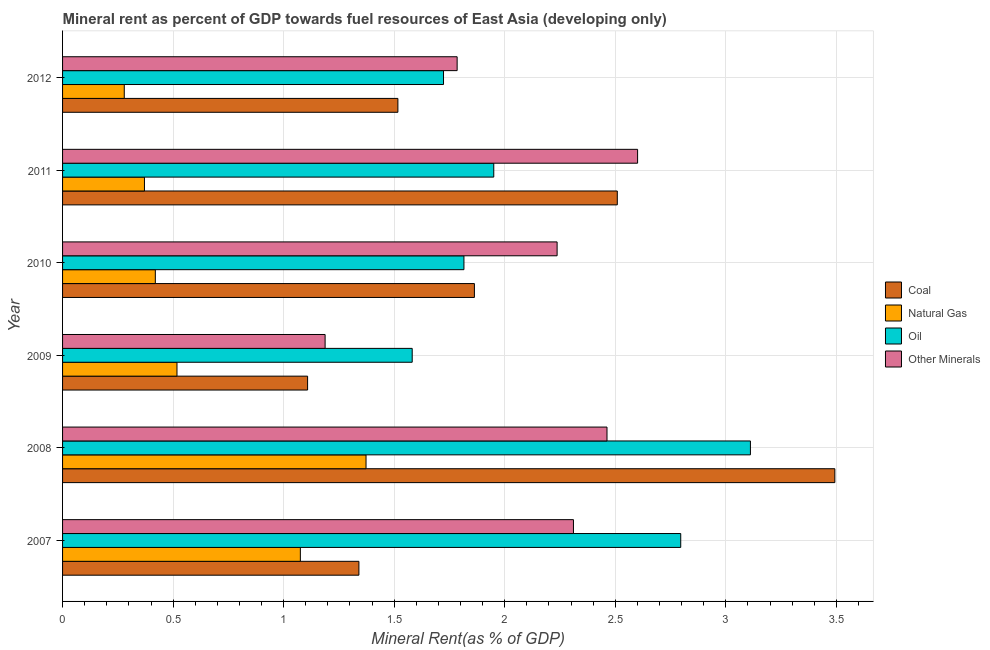How many different coloured bars are there?
Make the answer very short. 4. Are the number of bars on each tick of the Y-axis equal?
Offer a very short reply. Yes. How many bars are there on the 6th tick from the top?
Make the answer very short. 4. How many bars are there on the 4th tick from the bottom?
Ensure brevity in your answer.  4. What is the label of the 1st group of bars from the top?
Provide a succinct answer. 2012. In how many cases, is the number of bars for a given year not equal to the number of legend labels?
Provide a short and direct response. 0. What is the oil rent in 2009?
Your answer should be very brief. 1.58. Across all years, what is the maximum coal rent?
Keep it short and to the point. 3.49. Across all years, what is the minimum coal rent?
Your answer should be compact. 1.11. In which year was the natural gas rent minimum?
Offer a very short reply. 2012. What is the total coal rent in the graph?
Your answer should be very brief. 11.83. What is the difference between the coal rent in 2008 and that in 2012?
Your answer should be very brief. 1.98. What is the difference between the  rent of other minerals in 2010 and the oil rent in 2011?
Your answer should be compact. 0.29. What is the average oil rent per year?
Keep it short and to the point. 2.16. In the year 2012, what is the difference between the natural gas rent and  rent of other minerals?
Keep it short and to the point. -1.51. What is the ratio of the oil rent in 2007 to that in 2010?
Keep it short and to the point. 1.54. Is the coal rent in 2007 less than that in 2009?
Your answer should be very brief. No. Is the difference between the oil rent in 2007 and 2008 greater than the difference between the natural gas rent in 2007 and 2008?
Make the answer very short. No. What is the difference between the highest and the second highest natural gas rent?
Ensure brevity in your answer.  0.3. What is the difference between the highest and the lowest oil rent?
Ensure brevity in your answer.  1.53. In how many years, is the coal rent greater than the average coal rent taken over all years?
Your answer should be very brief. 2. Is the sum of the natural gas rent in 2007 and 2012 greater than the maximum  rent of other minerals across all years?
Keep it short and to the point. No. Is it the case that in every year, the sum of the natural gas rent and  rent of other minerals is greater than the sum of oil rent and coal rent?
Your response must be concise. No. What does the 1st bar from the top in 2008 represents?
Keep it short and to the point. Other Minerals. What does the 4th bar from the bottom in 2012 represents?
Provide a succinct answer. Other Minerals. What is the difference between two consecutive major ticks on the X-axis?
Provide a short and direct response. 0.5. Does the graph contain grids?
Keep it short and to the point. Yes. What is the title of the graph?
Your answer should be compact. Mineral rent as percent of GDP towards fuel resources of East Asia (developing only). What is the label or title of the X-axis?
Ensure brevity in your answer.  Mineral Rent(as % of GDP). What is the label or title of the Y-axis?
Your answer should be very brief. Year. What is the Mineral Rent(as % of GDP) in Coal in 2007?
Provide a short and direct response. 1.34. What is the Mineral Rent(as % of GDP) of Natural Gas in 2007?
Ensure brevity in your answer.  1.08. What is the Mineral Rent(as % of GDP) in Oil in 2007?
Your response must be concise. 2.8. What is the Mineral Rent(as % of GDP) of Other Minerals in 2007?
Your answer should be very brief. 2.31. What is the Mineral Rent(as % of GDP) in Coal in 2008?
Your answer should be compact. 3.49. What is the Mineral Rent(as % of GDP) in Natural Gas in 2008?
Keep it short and to the point. 1.37. What is the Mineral Rent(as % of GDP) of Oil in 2008?
Your answer should be very brief. 3.11. What is the Mineral Rent(as % of GDP) of Other Minerals in 2008?
Provide a short and direct response. 2.46. What is the Mineral Rent(as % of GDP) of Coal in 2009?
Offer a terse response. 1.11. What is the Mineral Rent(as % of GDP) of Natural Gas in 2009?
Keep it short and to the point. 0.52. What is the Mineral Rent(as % of GDP) in Oil in 2009?
Give a very brief answer. 1.58. What is the Mineral Rent(as % of GDP) of Other Minerals in 2009?
Offer a terse response. 1.19. What is the Mineral Rent(as % of GDP) of Coal in 2010?
Provide a short and direct response. 1.86. What is the Mineral Rent(as % of GDP) of Natural Gas in 2010?
Offer a terse response. 0.42. What is the Mineral Rent(as % of GDP) of Oil in 2010?
Your response must be concise. 1.82. What is the Mineral Rent(as % of GDP) in Other Minerals in 2010?
Offer a terse response. 2.24. What is the Mineral Rent(as % of GDP) in Coal in 2011?
Your response must be concise. 2.51. What is the Mineral Rent(as % of GDP) in Natural Gas in 2011?
Your response must be concise. 0.37. What is the Mineral Rent(as % of GDP) of Oil in 2011?
Provide a short and direct response. 1.95. What is the Mineral Rent(as % of GDP) of Other Minerals in 2011?
Provide a succinct answer. 2.6. What is the Mineral Rent(as % of GDP) in Coal in 2012?
Ensure brevity in your answer.  1.52. What is the Mineral Rent(as % of GDP) of Natural Gas in 2012?
Your response must be concise. 0.28. What is the Mineral Rent(as % of GDP) of Oil in 2012?
Keep it short and to the point. 1.72. What is the Mineral Rent(as % of GDP) in Other Minerals in 2012?
Provide a short and direct response. 1.78. Across all years, what is the maximum Mineral Rent(as % of GDP) in Coal?
Offer a very short reply. 3.49. Across all years, what is the maximum Mineral Rent(as % of GDP) in Natural Gas?
Your answer should be very brief. 1.37. Across all years, what is the maximum Mineral Rent(as % of GDP) in Oil?
Your answer should be compact. 3.11. Across all years, what is the maximum Mineral Rent(as % of GDP) of Other Minerals?
Your answer should be compact. 2.6. Across all years, what is the minimum Mineral Rent(as % of GDP) of Coal?
Your answer should be very brief. 1.11. Across all years, what is the minimum Mineral Rent(as % of GDP) in Natural Gas?
Give a very brief answer. 0.28. Across all years, what is the minimum Mineral Rent(as % of GDP) of Oil?
Offer a terse response. 1.58. Across all years, what is the minimum Mineral Rent(as % of GDP) in Other Minerals?
Give a very brief answer. 1.19. What is the total Mineral Rent(as % of GDP) of Coal in the graph?
Your response must be concise. 11.83. What is the total Mineral Rent(as % of GDP) of Natural Gas in the graph?
Your answer should be very brief. 4.03. What is the total Mineral Rent(as % of GDP) of Oil in the graph?
Your answer should be very brief. 12.98. What is the total Mineral Rent(as % of GDP) of Other Minerals in the graph?
Provide a short and direct response. 12.58. What is the difference between the Mineral Rent(as % of GDP) in Coal in 2007 and that in 2008?
Give a very brief answer. -2.15. What is the difference between the Mineral Rent(as % of GDP) of Natural Gas in 2007 and that in 2008?
Offer a very short reply. -0.3. What is the difference between the Mineral Rent(as % of GDP) of Oil in 2007 and that in 2008?
Your answer should be very brief. -0.32. What is the difference between the Mineral Rent(as % of GDP) in Other Minerals in 2007 and that in 2008?
Provide a short and direct response. -0.15. What is the difference between the Mineral Rent(as % of GDP) of Coal in 2007 and that in 2009?
Provide a succinct answer. 0.23. What is the difference between the Mineral Rent(as % of GDP) of Natural Gas in 2007 and that in 2009?
Your answer should be very brief. 0.56. What is the difference between the Mineral Rent(as % of GDP) of Oil in 2007 and that in 2009?
Keep it short and to the point. 1.21. What is the difference between the Mineral Rent(as % of GDP) of Other Minerals in 2007 and that in 2009?
Keep it short and to the point. 1.12. What is the difference between the Mineral Rent(as % of GDP) of Coal in 2007 and that in 2010?
Keep it short and to the point. -0.52. What is the difference between the Mineral Rent(as % of GDP) of Natural Gas in 2007 and that in 2010?
Ensure brevity in your answer.  0.66. What is the difference between the Mineral Rent(as % of GDP) in Oil in 2007 and that in 2010?
Ensure brevity in your answer.  0.98. What is the difference between the Mineral Rent(as % of GDP) of Other Minerals in 2007 and that in 2010?
Provide a succinct answer. 0.07. What is the difference between the Mineral Rent(as % of GDP) in Coal in 2007 and that in 2011?
Offer a terse response. -1.17. What is the difference between the Mineral Rent(as % of GDP) in Natural Gas in 2007 and that in 2011?
Offer a very short reply. 0.71. What is the difference between the Mineral Rent(as % of GDP) in Oil in 2007 and that in 2011?
Your response must be concise. 0.85. What is the difference between the Mineral Rent(as % of GDP) of Other Minerals in 2007 and that in 2011?
Ensure brevity in your answer.  -0.29. What is the difference between the Mineral Rent(as % of GDP) of Coal in 2007 and that in 2012?
Keep it short and to the point. -0.18. What is the difference between the Mineral Rent(as % of GDP) in Natural Gas in 2007 and that in 2012?
Your answer should be compact. 0.8. What is the difference between the Mineral Rent(as % of GDP) in Oil in 2007 and that in 2012?
Provide a succinct answer. 1.07. What is the difference between the Mineral Rent(as % of GDP) of Other Minerals in 2007 and that in 2012?
Offer a very short reply. 0.53. What is the difference between the Mineral Rent(as % of GDP) of Coal in 2008 and that in 2009?
Your answer should be compact. 2.38. What is the difference between the Mineral Rent(as % of GDP) of Natural Gas in 2008 and that in 2009?
Your answer should be compact. 0.86. What is the difference between the Mineral Rent(as % of GDP) in Oil in 2008 and that in 2009?
Your answer should be compact. 1.53. What is the difference between the Mineral Rent(as % of GDP) of Other Minerals in 2008 and that in 2009?
Offer a very short reply. 1.28. What is the difference between the Mineral Rent(as % of GDP) of Coal in 2008 and that in 2010?
Make the answer very short. 1.63. What is the difference between the Mineral Rent(as % of GDP) in Natural Gas in 2008 and that in 2010?
Provide a short and direct response. 0.95. What is the difference between the Mineral Rent(as % of GDP) of Oil in 2008 and that in 2010?
Offer a terse response. 1.3. What is the difference between the Mineral Rent(as % of GDP) in Other Minerals in 2008 and that in 2010?
Give a very brief answer. 0.23. What is the difference between the Mineral Rent(as % of GDP) in Natural Gas in 2008 and that in 2011?
Keep it short and to the point. 1. What is the difference between the Mineral Rent(as % of GDP) in Oil in 2008 and that in 2011?
Your answer should be very brief. 1.16. What is the difference between the Mineral Rent(as % of GDP) of Other Minerals in 2008 and that in 2011?
Provide a succinct answer. -0.14. What is the difference between the Mineral Rent(as % of GDP) in Coal in 2008 and that in 2012?
Your answer should be compact. 1.98. What is the difference between the Mineral Rent(as % of GDP) in Natural Gas in 2008 and that in 2012?
Provide a short and direct response. 1.09. What is the difference between the Mineral Rent(as % of GDP) in Oil in 2008 and that in 2012?
Provide a short and direct response. 1.39. What is the difference between the Mineral Rent(as % of GDP) in Other Minerals in 2008 and that in 2012?
Your response must be concise. 0.68. What is the difference between the Mineral Rent(as % of GDP) in Coal in 2009 and that in 2010?
Your response must be concise. -0.75. What is the difference between the Mineral Rent(as % of GDP) of Natural Gas in 2009 and that in 2010?
Offer a very short reply. 0.1. What is the difference between the Mineral Rent(as % of GDP) of Oil in 2009 and that in 2010?
Your answer should be compact. -0.23. What is the difference between the Mineral Rent(as % of GDP) of Other Minerals in 2009 and that in 2010?
Keep it short and to the point. -1.05. What is the difference between the Mineral Rent(as % of GDP) of Coal in 2009 and that in 2011?
Provide a short and direct response. -1.4. What is the difference between the Mineral Rent(as % of GDP) of Natural Gas in 2009 and that in 2011?
Provide a short and direct response. 0.15. What is the difference between the Mineral Rent(as % of GDP) in Oil in 2009 and that in 2011?
Provide a short and direct response. -0.37. What is the difference between the Mineral Rent(as % of GDP) in Other Minerals in 2009 and that in 2011?
Ensure brevity in your answer.  -1.41. What is the difference between the Mineral Rent(as % of GDP) of Coal in 2009 and that in 2012?
Make the answer very short. -0.41. What is the difference between the Mineral Rent(as % of GDP) of Natural Gas in 2009 and that in 2012?
Your response must be concise. 0.24. What is the difference between the Mineral Rent(as % of GDP) of Oil in 2009 and that in 2012?
Keep it short and to the point. -0.14. What is the difference between the Mineral Rent(as % of GDP) of Other Minerals in 2009 and that in 2012?
Offer a terse response. -0.6. What is the difference between the Mineral Rent(as % of GDP) of Coal in 2010 and that in 2011?
Offer a very short reply. -0.65. What is the difference between the Mineral Rent(as % of GDP) in Natural Gas in 2010 and that in 2011?
Make the answer very short. 0.05. What is the difference between the Mineral Rent(as % of GDP) in Oil in 2010 and that in 2011?
Offer a very short reply. -0.13. What is the difference between the Mineral Rent(as % of GDP) of Other Minerals in 2010 and that in 2011?
Give a very brief answer. -0.36. What is the difference between the Mineral Rent(as % of GDP) of Coal in 2010 and that in 2012?
Provide a short and direct response. 0.35. What is the difference between the Mineral Rent(as % of GDP) in Natural Gas in 2010 and that in 2012?
Provide a short and direct response. 0.14. What is the difference between the Mineral Rent(as % of GDP) of Oil in 2010 and that in 2012?
Your answer should be compact. 0.09. What is the difference between the Mineral Rent(as % of GDP) in Other Minerals in 2010 and that in 2012?
Offer a very short reply. 0.45. What is the difference between the Mineral Rent(as % of GDP) of Natural Gas in 2011 and that in 2012?
Your answer should be very brief. 0.09. What is the difference between the Mineral Rent(as % of GDP) in Oil in 2011 and that in 2012?
Your answer should be very brief. 0.23. What is the difference between the Mineral Rent(as % of GDP) in Other Minerals in 2011 and that in 2012?
Offer a very short reply. 0.82. What is the difference between the Mineral Rent(as % of GDP) in Coal in 2007 and the Mineral Rent(as % of GDP) in Natural Gas in 2008?
Offer a very short reply. -0.03. What is the difference between the Mineral Rent(as % of GDP) of Coal in 2007 and the Mineral Rent(as % of GDP) of Oil in 2008?
Your response must be concise. -1.77. What is the difference between the Mineral Rent(as % of GDP) in Coal in 2007 and the Mineral Rent(as % of GDP) in Other Minerals in 2008?
Give a very brief answer. -1.12. What is the difference between the Mineral Rent(as % of GDP) of Natural Gas in 2007 and the Mineral Rent(as % of GDP) of Oil in 2008?
Offer a very short reply. -2.04. What is the difference between the Mineral Rent(as % of GDP) of Natural Gas in 2007 and the Mineral Rent(as % of GDP) of Other Minerals in 2008?
Offer a very short reply. -1.39. What is the difference between the Mineral Rent(as % of GDP) of Oil in 2007 and the Mineral Rent(as % of GDP) of Other Minerals in 2008?
Keep it short and to the point. 0.33. What is the difference between the Mineral Rent(as % of GDP) of Coal in 2007 and the Mineral Rent(as % of GDP) of Natural Gas in 2009?
Provide a short and direct response. 0.82. What is the difference between the Mineral Rent(as % of GDP) of Coal in 2007 and the Mineral Rent(as % of GDP) of Oil in 2009?
Give a very brief answer. -0.24. What is the difference between the Mineral Rent(as % of GDP) in Coal in 2007 and the Mineral Rent(as % of GDP) in Other Minerals in 2009?
Your answer should be compact. 0.15. What is the difference between the Mineral Rent(as % of GDP) in Natural Gas in 2007 and the Mineral Rent(as % of GDP) in Oil in 2009?
Your response must be concise. -0.51. What is the difference between the Mineral Rent(as % of GDP) in Natural Gas in 2007 and the Mineral Rent(as % of GDP) in Other Minerals in 2009?
Ensure brevity in your answer.  -0.11. What is the difference between the Mineral Rent(as % of GDP) in Oil in 2007 and the Mineral Rent(as % of GDP) in Other Minerals in 2009?
Your answer should be very brief. 1.61. What is the difference between the Mineral Rent(as % of GDP) of Coal in 2007 and the Mineral Rent(as % of GDP) of Natural Gas in 2010?
Your answer should be compact. 0.92. What is the difference between the Mineral Rent(as % of GDP) of Coal in 2007 and the Mineral Rent(as % of GDP) of Oil in 2010?
Your answer should be compact. -0.47. What is the difference between the Mineral Rent(as % of GDP) of Coal in 2007 and the Mineral Rent(as % of GDP) of Other Minerals in 2010?
Provide a succinct answer. -0.9. What is the difference between the Mineral Rent(as % of GDP) of Natural Gas in 2007 and the Mineral Rent(as % of GDP) of Oil in 2010?
Offer a very short reply. -0.74. What is the difference between the Mineral Rent(as % of GDP) in Natural Gas in 2007 and the Mineral Rent(as % of GDP) in Other Minerals in 2010?
Make the answer very short. -1.16. What is the difference between the Mineral Rent(as % of GDP) in Oil in 2007 and the Mineral Rent(as % of GDP) in Other Minerals in 2010?
Your answer should be very brief. 0.56. What is the difference between the Mineral Rent(as % of GDP) in Coal in 2007 and the Mineral Rent(as % of GDP) in Natural Gas in 2011?
Offer a terse response. 0.97. What is the difference between the Mineral Rent(as % of GDP) of Coal in 2007 and the Mineral Rent(as % of GDP) of Oil in 2011?
Provide a succinct answer. -0.61. What is the difference between the Mineral Rent(as % of GDP) of Coal in 2007 and the Mineral Rent(as % of GDP) of Other Minerals in 2011?
Your answer should be very brief. -1.26. What is the difference between the Mineral Rent(as % of GDP) of Natural Gas in 2007 and the Mineral Rent(as % of GDP) of Oil in 2011?
Give a very brief answer. -0.87. What is the difference between the Mineral Rent(as % of GDP) of Natural Gas in 2007 and the Mineral Rent(as % of GDP) of Other Minerals in 2011?
Your answer should be very brief. -1.53. What is the difference between the Mineral Rent(as % of GDP) in Oil in 2007 and the Mineral Rent(as % of GDP) in Other Minerals in 2011?
Your answer should be very brief. 0.2. What is the difference between the Mineral Rent(as % of GDP) of Coal in 2007 and the Mineral Rent(as % of GDP) of Natural Gas in 2012?
Make the answer very short. 1.06. What is the difference between the Mineral Rent(as % of GDP) of Coal in 2007 and the Mineral Rent(as % of GDP) of Oil in 2012?
Your response must be concise. -0.38. What is the difference between the Mineral Rent(as % of GDP) of Coal in 2007 and the Mineral Rent(as % of GDP) of Other Minerals in 2012?
Your answer should be very brief. -0.44. What is the difference between the Mineral Rent(as % of GDP) of Natural Gas in 2007 and the Mineral Rent(as % of GDP) of Oil in 2012?
Your response must be concise. -0.65. What is the difference between the Mineral Rent(as % of GDP) of Natural Gas in 2007 and the Mineral Rent(as % of GDP) of Other Minerals in 2012?
Keep it short and to the point. -0.71. What is the difference between the Mineral Rent(as % of GDP) of Oil in 2007 and the Mineral Rent(as % of GDP) of Other Minerals in 2012?
Give a very brief answer. 1.01. What is the difference between the Mineral Rent(as % of GDP) of Coal in 2008 and the Mineral Rent(as % of GDP) of Natural Gas in 2009?
Provide a succinct answer. 2.98. What is the difference between the Mineral Rent(as % of GDP) in Coal in 2008 and the Mineral Rent(as % of GDP) in Oil in 2009?
Provide a short and direct response. 1.91. What is the difference between the Mineral Rent(as % of GDP) of Coal in 2008 and the Mineral Rent(as % of GDP) of Other Minerals in 2009?
Ensure brevity in your answer.  2.31. What is the difference between the Mineral Rent(as % of GDP) of Natural Gas in 2008 and the Mineral Rent(as % of GDP) of Oil in 2009?
Your answer should be very brief. -0.21. What is the difference between the Mineral Rent(as % of GDP) in Natural Gas in 2008 and the Mineral Rent(as % of GDP) in Other Minerals in 2009?
Ensure brevity in your answer.  0.19. What is the difference between the Mineral Rent(as % of GDP) in Oil in 2008 and the Mineral Rent(as % of GDP) in Other Minerals in 2009?
Offer a terse response. 1.92. What is the difference between the Mineral Rent(as % of GDP) in Coal in 2008 and the Mineral Rent(as % of GDP) in Natural Gas in 2010?
Provide a succinct answer. 3.07. What is the difference between the Mineral Rent(as % of GDP) in Coal in 2008 and the Mineral Rent(as % of GDP) in Oil in 2010?
Offer a terse response. 1.68. What is the difference between the Mineral Rent(as % of GDP) of Coal in 2008 and the Mineral Rent(as % of GDP) of Other Minerals in 2010?
Offer a terse response. 1.26. What is the difference between the Mineral Rent(as % of GDP) in Natural Gas in 2008 and the Mineral Rent(as % of GDP) in Oil in 2010?
Your response must be concise. -0.44. What is the difference between the Mineral Rent(as % of GDP) of Natural Gas in 2008 and the Mineral Rent(as % of GDP) of Other Minerals in 2010?
Ensure brevity in your answer.  -0.86. What is the difference between the Mineral Rent(as % of GDP) in Oil in 2008 and the Mineral Rent(as % of GDP) in Other Minerals in 2010?
Give a very brief answer. 0.87. What is the difference between the Mineral Rent(as % of GDP) in Coal in 2008 and the Mineral Rent(as % of GDP) in Natural Gas in 2011?
Provide a short and direct response. 3.12. What is the difference between the Mineral Rent(as % of GDP) in Coal in 2008 and the Mineral Rent(as % of GDP) in Oil in 2011?
Offer a very short reply. 1.54. What is the difference between the Mineral Rent(as % of GDP) of Coal in 2008 and the Mineral Rent(as % of GDP) of Other Minerals in 2011?
Give a very brief answer. 0.89. What is the difference between the Mineral Rent(as % of GDP) in Natural Gas in 2008 and the Mineral Rent(as % of GDP) in Oil in 2011?
Offer a terse response. -0.58. What is the difference between the Mineral Rent(as % of GDP) of Natural Gas in 2008 and the Mineral Rent(as % of GDP) of Other Minerals in 2011?
Give a very brief answer. -1.23. What is the difference between the Mineral Rent(as % of GDP) in Oil in 2008 and the Mineral Rent(as % of GDP) in Other Minerals in 2011?
Provide a short and direct response. 0.51. What is the difference between the Mineral Rent(as % of GDP) of Coal in 2008 and the Mineral Rent(as % of GDP) of Natural Gas in 2012?
Your response must be concise. 3.21. What is the difference between the Mineral Rent(as % of GDP) in Coal in 2008 and the Mineral Rent(as % of GDP) in Oil in 2012?
Keep it short and to the point. 1.77. What is the difference between the Mineral Rent(as % of GDP) of Coal in 2008 and the Mineral Rent(as % of GDP) of Other Minerals in 2012?
Provide a succinct answer. 1.71. What is the difference between the Mineral Rent(as % of GDP) in Natural Gas in 2008 and the Mineral Rent(as % of GDP) in Oil in 2012?
Your response must be concise. -0.35. What is the difference between the Mineral Rent(as % of GDP) of Natural Gas in 2008 and the Mineral Rent(as % of GDP) of Other Minerals in 2012?
Ensure brevity in your answer.  -0.41. What is the difference between the Mineral Rent(as % of GDP) of Oil in 2008 and the Mineral Rent(as % of GDP) of Other Minerals in 2012?
Your answer should be very brief. 1.33. What is the difference between the Mineral Rent(as % of GDP) in Coal in 2009 and the Mineral Rent(as % of GDP) in Natural Gas in 2010?
Make the answer very short. 0.69. What is the difference between the Mineral Rent(as % of GDP) in Coal in 2009 and the Mineral Rent(as % of GDP) in Oil in 2010?
Provide a succinct answer. -0.71. What is the difference between the Mineral Rent(as % of GDP) in Coal in 2009 and the Mineral Rent(as % of GDP) in Other Minerals in 2010?
Ensure brevity in your answer.  -1.13. What is the difference between the Mineral Rent(as % of GDP) of Natural Gas in 2009 and the Mineral Rent(as % of GDP) of Oil in 2010?
Offer a very short reply. -1.3. What is the difference between the Mineral Rent(as % of GDP) of Natural Gas in 2009 and the Mineral Rent(as % of GDP) of Other Minerals in 2010?
Give a very brief answer. -1.72. What is the difference between the Mineral Rent(as % of GDP) of Oil in 2009 and the Mineral Rent(as % of GDP) of Other Minerals in 2010?
Your answer should be compact. -0.66. What is the difference between the Mineral Rent(as % of GDP) of Coal in 2009 and the Mineral Rent(as % of GDP) of Natural Gas in 2011?
Provide a short and direct response. 0.74. What is the difference between the Mineral Rent(as % of GDP) of Coal in 2009 and the Mineral Rent(as % of GDP) of Oil in 2011?
Ensure brevity in your answer.  -0.84. What is the difference between the Mineral Rent(as % of GDP) in Coal in 2009 and the Mineral Rent(as % of GDP) in Other Minerals in 2011?
Make the answer very short. -1.49. What is the difference between the Mineral Rent(as % of GDP) in Natural Gas in 2009 and the Mineral Rent(as % of GDP) in Oil in 2011?
Give a very brief answer. -1.43. What is the difference between the Mineral Rent(as % of GDP) of Natural Gas in 2009 and the Mineral Rent(as % of GDP) of Other Minerals in 2011?
Your response must be concise. -2.08. What is the difference between the Mineral Rent(as % of GDP) in Oil in 2009 and the Mineral Rent(as % of GDP) in Other Minerals in 2011?
Provide a succinct answer. -1.02. What is the difference between the Mineral Rent(as % of GDP) of Coal in 2009 and the Mineral Rent(as % of GDP) of Natural Gas in 2012?
Ensure brevity in your answer.  0.83. What is the difference between the Mineral Rent(as % of GDP) of Coal in 2009 and the Mineral Rent(as % of GDP) of Oil in 2012?
Give a very brief answer. -0.61. What is the difference between the Mineral Rent(as % of GDP) of Coal in 2009 and the Mineral Rent(as % of GDP) of Other Minerals in 2012?
Provide a succinct answer. -0.68. What is the difference between the Mineral Rent(as % of GDP) in Natural Gas in 2009 and the Mineral Rent(as % of GDP) in Oil in 2012?
Provide a short and direct response. -1.21. What is the difference between the Mineral Rent(as % of GDP) in Natural Gas in 2009 and the Mineral Rent(as % of GDP) in Other Minerals in 2012?
Provide a short and direct response. -1.27. What is the difference between the Mineral Rent(as % of GDP) in Oil in 2009 and the Mineral Rent(as % of GDP) in Other Minerals in 2012?
Keep it short and to the point. -0.2. What is the difference between the Mineral Rent(as % of GDP) of Coal in 2010 and the Mineral Rent(as % of GDP) of Natural Gas in 2011?
Provide a succinct answer. 1.49. What is the difference between the Mineral Rent(as % of GDP) of Coal in 2010 and the Mineral Rent(as % of GDP) of Oil in 2011?
Offer a terse response. -0.09. What is the difference between the Mineral Rent(as % of GDP) of Coal in 2010 and the Mineral Rent(as % of GDP) of Other Minerals in 2011?
Provide a succinct answer. -0.74. What is the difference between the Mineral Rent(as % of GDP) of Natural Gas in 2010 and the Mineral Rent(as % of GDP) of Oil in 2011?
Provide a succinct answer. -1.53. What is the difference between the Mineral Rent(as % of GDP) of Natural Gas in 2010 and the Mineral Rent(as % of GDP) of Other Minerals in 2011?
Your response must be concise. -2.18. What is the difference between the Mineral Rent(as % of GDP) in Oil in 2010 and the Mineral Rent(as % of GDP) in Other Minerals in 2011?
Offer a very short reply. -0.79. What is the difference between the Mineral Rent(as % of GDP) in Coal in 2010 and the Mineral Rent(as % of GDP) in Natural Gas in 2012?
Ensure brevity in your answer.  1.58. What is the difference between the Mineral Rent(as % of GDP) of Coal in 2010 and the Mineral Rent(as % of GDP) of Oil in 2012?
Keep it short and to the point. 0.14. What is the difference between the Mineral Rent(as % of GDP) of Coal in 2010 and the Mineral Rent(as % of GDP) of Other Minerals in 2012?
Provide a short and direct response. 0.08. What is the difference between the Mineral Rent(as % of GDP) in Natural Gas in 2010 and the Mineral Rent(as % of GDP) in Oil in 2012?
Give a very brief answer. -1.3. What is the difference between the Mineral Rent(as % of GDP) of Natural Gas in 2010 and the Mineral Rent(as % of GDP) of Other Minerals in 2012?
Your answer should be compact. -1.37. What is the difference between the Mineral Rent(as % of GDP) in Oil in 2010 and the Mineral Rent(as % of GDP) in Other Minerals in 2012?
Ensure brevity in your answer.  0.03. What is the difference between the Mineral Rent(as % of GDP) in Coal in 2011 and the Mineral Rent(as % of GDP) in Natural Gas in 2012?
Give a very brief answer. 2.23. What is the difference between the Mineral Rent(as % of GDP) in Coal in 2011 and the Mineral Rent(as % of GDP) in Oil in 2012?
Offer a very short reply. 0.79. What is the difference between the Mineral Rent(as % of GDP) in Coal in 2011 and the Mineral Rent(as % of GDP) in Other Minerals in 2012?
Provide a succinct answer. 0.72. What is the difference between the Mineral Rent(as % of GDP) in Natural Gas in 2011 and the Mineral Rent(as % of GDP) in Oil in 2012?
Your answer should be compact. -1.35. What is the difference between the Mineral Rent(as % of GDP) in Natural Gas in 2011 and the Mineral Rent(as % of GDP) in Other Minerals in 2012?
Your answer should be very brief. -1.41. What is the difference between the Mineral Rent(as % of GDP) of Oil in 2011 and the Mineral Rent(as % of GDP) of Other Minerals in 2012?
Make the answer very short. 0.17. What is the average Mineral Rent(as % of GDP) of Coal per year?
Provide a succinct answer. 1.97. What is the average Mineral Rent(as % of GDP) in Natural Gas per year?
Offer a terse response. 0.67. What is the average Mineral Rent(as % of GDP) in Oil per year?
Provide a short and direct response. 2.16. What is the average Mineral Rent(as % of GDP) of Other Minerals per year?
Give a very brief answer. 2.1. In the year 2007, what is the difference between the Mineral Rent(as % of GDP) in Coal and Mineral Rent(as % of GDP) in Natural Gas?
Make the answer very short. 0.26. In the year 2007, what is the difference between the Mineral Rent(as % of GDP) in Coal and Mineral Rent(as % of GDP) in Oil?
Ensure brevity in your answer.  -1.46. In the year 2007, what is the difference between the Mineral Rent(as % of GDP) of Coal and Mineral Rent(as % of GDP) of Other Minerals?
Keep it short and to the point. -0.97. In the year 2007, what is the difference between the Mineral Rent(as % of GDP) of Natural Gas and Mineral Rent(as % of GDP) of Oil?
Your answer should be very brief. -1.72. In the year 2007, what is the difference between the Mineral Rent(as % of GDP) of Natural Gas and Mineral Rent(as % of GDP) of Other Minerals?
Ensure brevity in your answer.  -1.24. In the year 2007, what is the difference between the Mineral Rent(as % of GDP) in Oil and Mineral Rent(as % of GDP) in Other Minerals?
Offer a terse response. 0.49. In the year 2008, what is the difference between the Mineral Rent(as % of GDP) of Coal and Mineral Rent(as % of GDP) of Natural Gas?
Your answer should be compact. 2.12. In the year 2008, what is the difference between the Mineral Rent(as % of GDP) of Coal and Mineral Rent(as % of GDP) of Oil?
Provide a succinct answer. 0.38. In the year 2008, what is the difference between the Mineral Rent(as % of GDP) of Coal and Mineral Rent(as % of GDP) of Other Minerals?
Make the answer very short. 1.03. In the year 2008, what is the difference between the Mineral Rent(as % of GDP) in Natural Gas and Mineral Rent(as % of GDP) in Oil?
Your answer should be compact. -1.74. In the year 2008, what is the difference between the Mineral Rent(as % of GDP) of Natural Gas and Mineral Rent(as % of GDP) of Other Minerals?
Offer a very short reply. -1.09. In the year 2008, what is the difference between the Mineral Rent(as % of GDP) in Oil and Mineral Rent(as % of GDP) in Other Minerals?
Ensure brevity in your answer.  0.65. In the year 2009, what is the difference between the Mineral Rent(as % of GDP) of Coal and Mineral Rent(as % of GDP) of Natural Gas?
Offer a very short reply. 0.59. In the year 2009, what is the difference between the Mineral Rent(as % of GDP) in Coal and Mineral Rent(as % of GDP) in Oil?
Your answer should be very brief. -0.47. In the year 2009, what is the difference between the Mineral Rent(as % of GDP) in Coal and Mineral Rent(as % of GDP) in Other Minerals?
Your answer should be very brief. -0.08. In the year 2009, what is the difference between the Mineral Rent(as % of GDP) of Natural Gas and Mineral Rent(as % of GDP) of Oil?
Provide a succinct answer. -1.06. In the year 2009, what is the difference between the Mineral Rent(as % of GDP) in Natural Gas and Mineral Rent(as % of GDP) in Other Minerals?
Keep it short and to the point. -0.67. In the year 2009, what is the difference between the Mineral Rent(as % of GDP) in Oil and Mineral Rent(as % of GDP) in Other Minerals?
Offer a very short reply. 0.39. In the year 2010, what is the difference between the Mineral Rent(as % of GDP) in Coal and Mineral Rent(as % of GDP) in Natural Gas?
Offer a terse response. 1.44. In the year 2010, what is the difference between the Mineral Rent(as % of GDP) in Coal and Mineral Rent(as % of GDP) in Oil?
Keep it short and to the point. 0.05. In the year 2010, what is the difference between the Mineral Rent(as % of GDP) in Coal and Mineral Rent(as % of GDP) in Other Minerals?
Ensure brevity in your answer.  -0.37. In the year 2010, what is the difference between the Mineral Rent(as % of GDP) of Natural Gas and Mineral Rent(as % of GDP) of Oil?
Make the answer very short. -1.4. In the year 2010, what is the difference between the Mineral Rent(as % of GDP) of Natural Gas and Mineral Rent(as % of GDP) of Other Minerals?
Ensure brevity in your answer.  -1.82. In the year 2010, what is the difference between the Mineral Rent(as % of GDP) in Oil and Mineral Rent(as % of GDP) in Other Minerals?
Offer a very short reply. -0.42. In the year 2011, what is the difference between the Mineral Rent(as % of GDP) in Coal and Mineral Rent(as % of GDP) in Natural Gas?
Your answer should be very brief. 2.14. In the year 2011, what is the difference between the Mineral Rent(as % of GDP) of Coal and Mineral Rent(as % of GDP) of Oil?
Provide a succinct answer. 0.56. In the year 2011, what is the difference between the Mineral Rent(as % of GDP) of Coal and Mineral Rent(as % of GDP) of Other Minerals?
Your answer should be very brief. -0.09. In the year 2011, what is the difference between the Mineral Rent(as % of GDP) of Natural Gas and Mineral Rent(as % of GDP) of Oil?
Provide a short and direct response. -1.58. In the year 2011, what is the difference between the Mineral Rent(as % of GDP) in Natural Gas and Mineral Rent(as % of GDP) in Other Minerals?
Give a very brief answer. -2.23. In the year 2011, what is the difference between the Mineral Rent(as % of GDP) in Oil and Mineral Rent(as % of GDP) in Other Minerals?
Provide a short and direct response. -0.65. In the year 2012, what is the difference between the Mineral Rent(as % of GDP) of Coal and Mineral Rent(as % of GDP) of Natural Gas?
Provide a short and direct response. 1.24. In the year 2012, what is the difference between the Mineral Rent(as % of GDP) of Coal and Mineral Rent(as % of GDP) of Oil?
Make the answer very short. -0.21. In the year 2012, what is the difference between the Mineral Rent(as % of GDP) in Coal and Mineral Rent(as % of GDP) in Other Minerals?
Provide a short and direct response. -0.27. In the year 2012, what is the difference between the Mineral Rent(as % of GDP) in Natural Gas and Mineral Rent(as % of GDP) in Oil?
Make the answer very short. -1.44. In the year 2012, what is the difference between the Mineral Rent(as % of GDP) in Natural Gas and Mineral Rent(as % of GDP) in Other Minerals?
Your answer should be very brief. -1.51. In the year 2012, what is the difference between the Mineral Rent(as % of GDP) of Oil and Mineral Rent(as % of GDP) of Other Minerals?
Offer a terse response. -0.06. What is the ratio of the Mineral Rent(as % of GDP) of Coal in 2007 to that in 2008?
Offer a very short reply. 0.38. What is the ratio of the Mineral Rent(as % of GDP) in Natural Gas in 2007 to that in 2008?
Your answer should be very brief. 0.78. What is the ratio of the Mineral Rent(as % of GDP) of Oil in 2007 to that in 2008?
Your answer should be compact. 0.9. What is the ratio of the Mineral Rent(as % of GDP) of Other Minerals in 2007 to that in 2008?
Your answer should be very brief. 0.94. What is the ratio of the Mineral Rent(as % of GDP) in Coal in 2007 to that in 2009?
Offer a very short reply. 1.21. What is the ratio of the Mineral Rent(as % of GDP) in Natural Gas in 2007 to that in 2009?
Provide a short and direct response. 2.08. What is the ratio of the Mineral Rent(as % of GDP) of Oil in 2007 to that in 2009?
Make the answer very short. 1.77. What is the ratio of the Mineral Rent(as % of GDP) of Other Minerals in 2007 to that in 2009?
Your answer should be very brief. 1.95. What is the ratio of the Mineral Rent(as % of GDP) in Coal in 2007 to that in 2010?
Keep it short and to the point. 0.72. What is the ratio of the Mineral Rent(as % of GDP) of Natural Gas in 2007 to that in 2010?
Make the answer very short. 2.56. What is the ratio of the Mineral Rent(as % of GDP) of Oil in 2007 to that in 2010?
Your answer should be very brief. 1.54. What is the ratio of the Mineral Rent(as % of GDP) of Other Minerals in 2007 to that in 2010?
Ensure brevity in your answer.  1.03. What is the ratio of the Mineral Rent(as % of GDP) of Coal in 2007 to that in 2011?
Your answer should be very brief. 0.53. What is the ratio of the Mineral Rent(as % of GDP) of Natural Gas in 2007 to that in 2011?
Keep it short and to the point. 2.9. What is the ratio of the Mineral Rent(as % of GDP) in Oil in 2007 to that in 2011?
Your response must be concise. 1.43. What is the ratio of the Mineral Rent(as % of GDP) of Other Minerals in 2007 to that in 2011?
Your answer should be compact. 0.89. What is the ratio of the Mineral Rent(as % of GDP) of Coal in 2007 to that in 2012?
Your answer should be compact. 0.88. What is the ratio of the Mineral Rent(as % of GDP) in Natural Gas in 2007 to that in 2012?
Ensure brevity in your answer.  3.85. What is the ratio of the Mineral Rent(as % of GDP) of Oil in 2007 to that in 2012?
Offer a terse response. 1.62. What is the ratio of the Mineral Rent(as % of GDP) of Other Minerals in 2007 to that in 2012?
Offer a very short reply. 1.29. What is the ratio of the Mineral Rent(as % of GDP) in Coal in 2008 to that in 2009?
Ensure brevity in your answer.  3.15. What is the ratio of the Mineral Rent(as % of GDP) in Natural Gas in 2008 to that in 2009?
Your answer should be compact. 2.65. What is the ratio of the Mineral Rent(as % of GDP) of Oil in 2008 to that in 2009?
Your answer should be very brief. 1.97. What is the ratio of the Mineral Rent(as % of GDP) of Other Minerals in 2008 to that in 2009?
Your response must be concise. 2.07. What is the ratio of the Mineral Rent(as % of GDP) in Coal in 2008 to that in 2010?
Provide a short and direct response. 1.88. What is the ratio of the Mineral Rent(as % of GDP) of Natural Gas in 2008 to that in 2010?
Your response must be concise. 3.27. What is the ratio of the Mineral Rent(as % of GDP) of Oil in 2008 to that in 2010?
Keep it short and to the point. 1.71. What is the ratio of the Mineral Rent(as % of GDP) in Other Minerals in 2008 to that in 2010?
Offer a very short reply. 1.1. What is the ratio of the Mineral Rent(as % of GDP) of Coal in 2008 to that in 2011?
Ensure brevity in your answer.  1.39. What is the ratio of the Mineral Rent(as % of GDP) in Natural Gas in 2008 to that in 2011?
Provide a succinct answer. 3.71. What is the ratio of the Mineral Rent(as % of GDP) in Oil in 2008 to that in 2011?
Ensure brevity in your answer.  1.6. What is the ratio of the Mineral Rent(as % of GDP) of Other Minerals in 2008 to that in 2011?
Offer a very short reply. 0.95. What is the ratio of the Mineral Rent(as % of GDP) in Coal in 2008 to that in 2012?
Give a very brief answer. 2.3. What is the ratio of the Mineral Rent(as % of GDP) in Natural Gas in 2008 to that in 2012?
Your answer should be compact. 4.92. What is the ratio of the Mineral Rent(as % of GDP) in Oil in 2008 to that in 2012?
Offer a terse response. 1.81. What is the ratio of the Mineral Rent(as % of GDP) in Other Minerals in 2008 to that in 2012?
Keep it short and to the point. 1.38. What is the ratio of the Mineral Rent(as % of GDP) of Coal in 2009 to that in 2010?
Ensure brevity in your answer.  0.59. What is the ratio of the Mineral Rent(as % of GDP) in Natural Gas in 2009 to that in 2010?
Keep it short and to the point. 1.23. What is the ratio of the Mineral Rent(as % of GDP) in Oil in 2009 to that in 2010?
Your answer should be compact. 0.87. What is the ratio of the Mineral Rent(as % of GDP) of Other Minerals in 2009 to that in 2010?
Offer a terse response. 0.53. What is the ratio of the Mineral Rent(as % of GDP) of Coal in 2009 to that in 2011?
Offer a very short reply. 0.44. What is the ratio of the Mineral Rent(as % of GDP) of Natural Gas in 2009 to that in 2011?
Provide a succinct answer. 1.4. What is the ratio of the Mineral Rent(as % of GDP) in Oil in 2009 to that in 2011?
Make the answer very short. 0.81. What is the ratio of the Mineral Rent(as % of GDP) of Other Minerals in 2009 to that in 2011?
Provide a succinct answer. 0.46. What is the ratio of the Mineral Rent(as % of GDP) of Coal in 2009 to that in 2012?
Your answer should be very brief. 0.73. What is the ratio of the Mineral Rent(as % of GDP) of Natural Gas in 2009 to that in 2012?
Make the answer very short. 1.85. What is the ratio of the Mineral Rent(as % of GDP) of Oil in 2009 to that in 2012?
Provide a short and direct response. 0.92. What is the ratio of the Mineral Rent(as % of GDP) in Other Minerals in 2009 to that in 2012?
Your response must be concise. 0.67. What is the ratio of the Mineral Rent(as % of GDP) of Coal in 2010 to that in 2011?
Keep it short and to the point. 0.74. What is the ratio of the Mineral Rent(as % of GDP) of Natural Gas in 2010 to that in 2011?
Provide a succinct answer. 1.13. What is the ratio of the Mineral Rent(as % of GDP) in Oil in 2010 to that in 2011?
Provide a succinct answer. 0.93. What is the ratio of the Mineral Rent(as % of GDP) of Other Minerals in 2010 to that in 2011?
Offer a terse response. 0.86. What is the ratio of the Mineral Rent(as % of GDP) of Coal in 2010 to that in 2012?
Ensure brevity in your answer.  1.23. What is the ratio of the Mineral Rent(as % of GDP) in Natural Gas in 2010 to that in 2012?
Keep it short and to the point. 1.5. What is the ratio of the Mineral Rent(as % of GDP) in Oil in 2010 to that in 2012?
Give a very brief answer. 1.05. What is the ratio of the Mineral Rent(as % of GDP) in Other Minerals in 2010 to that in 2012?
Make the answer very short. 1.25. What is the ratio of the Mineral Rent(as % of GDP) of Coal in 2011 to that in 2012?
Provide a succinct answer. 1.65. What is the ratio of the Mineral Rent(as % of GDP) of Natural Gas in 2011 to that in 2012?
Keep it short and to the point. 1.33. What is the ratio of the Mineral Rent(as % of GDP) of Oil in 2011 to that in 2012?
Your response must be concise. 1.13. What is the ratio of the Mineral Rent(as % of GDP) in Other Minerals in 2011 to that in 2012?
Your answer should be compact. 1.46. What is the difference between the highest and the second highest Mineral Rent(as % of GDP) of Natural Gas?
Your answer should be compact. 0.3. What is the difference between the highest and the second highest Mineral Rent(as % of GDP) in Oil?
Provide a short and direct response. 0.32. What is the difference between the highest and the second highest Mineral Rent(as % of GDP) of Other Minerals?
Make the answer very short. 0.14. What is the difference between the highest and the lowest Mineral Rent(as % of GDP) of Coal?
Give a very brief answer. 2.38. What is the difference between the highest and the lowest Mineral Rent(as % of GDP) of Natural Gas?
Ensure brevity in your answer.  1.09. What is the difference between the highest and the lowest Mineral Rent(as % of GDP) in Oil?
Your answer should be compact. 1.53. What is the difference between the highest and the lowest Mineral Rent(as % of GDP) in Other Minerals?
Make the answer very short. 1.41. 